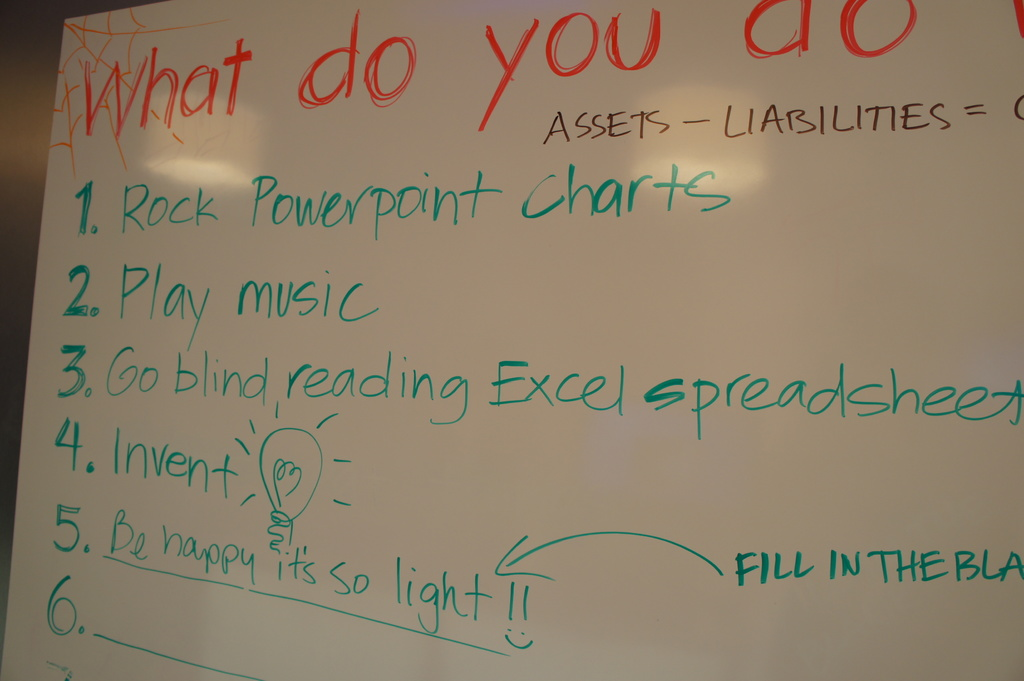Describe the following image. The image shows a whiteboard used during a brainstorming session, exploring creative and humorous strategies to manage assets, liabilities, and equity. The whiteboard lists five innovative suggestions: 1. 'Rock PowerPoint Charts', highlighting the use of compelling visual presentations. 2. 'Play music,' which proposes using artistic inspiration to enhance productivity. 3. 'Go blind reading Excel spreadsheets,' a humorous take on traditional intense data analysis. 4. 'Invent,' underscored by a sketch of a lightbulb, illustrating the drive for innovation. 5. 'Be happy it's so light,' celebrating the simplicity or ease of the task at hand. A sixth space is left blank, tagged 'FILL IN THE BLANK,' inviting further creative contributions. This photograph captures a moment of light-hearted yet purposeful deliberation, reflecting a blend of creativity, humor, and innovation in problem-solving. 